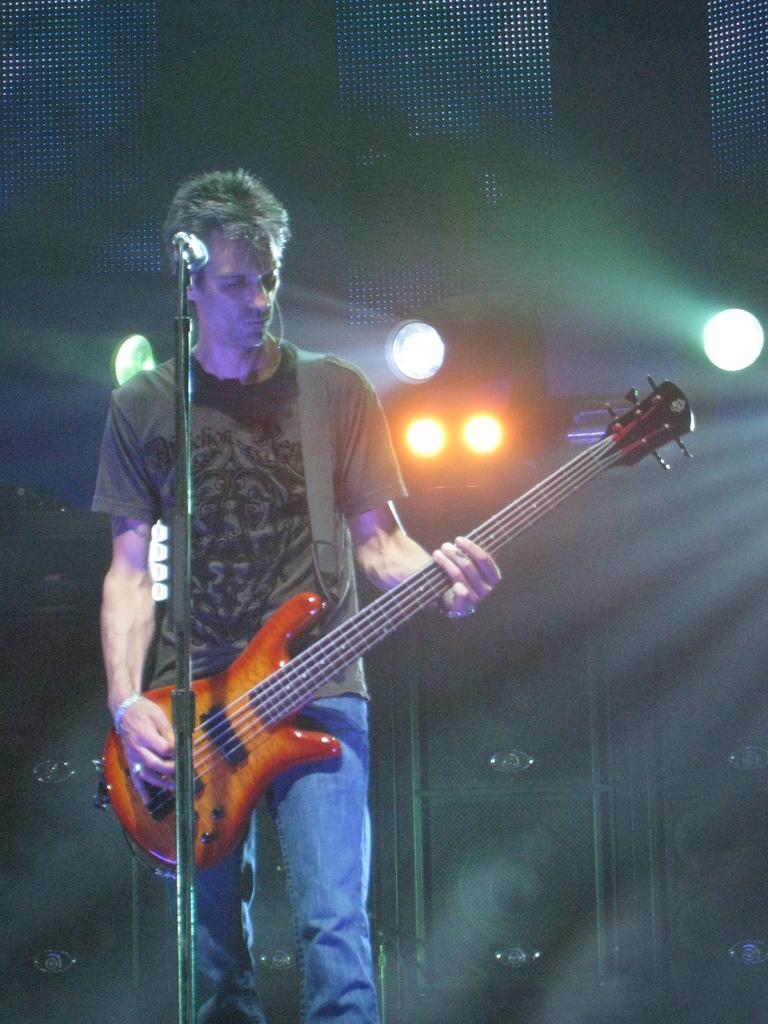Describe this image in one or two sentences. In this picture I can see there is a man standing and he is playing a guitar and is looking at it. There is a microphone in front of him, with a microphone stand and in the backdrop there are few speakers and there are lights. 